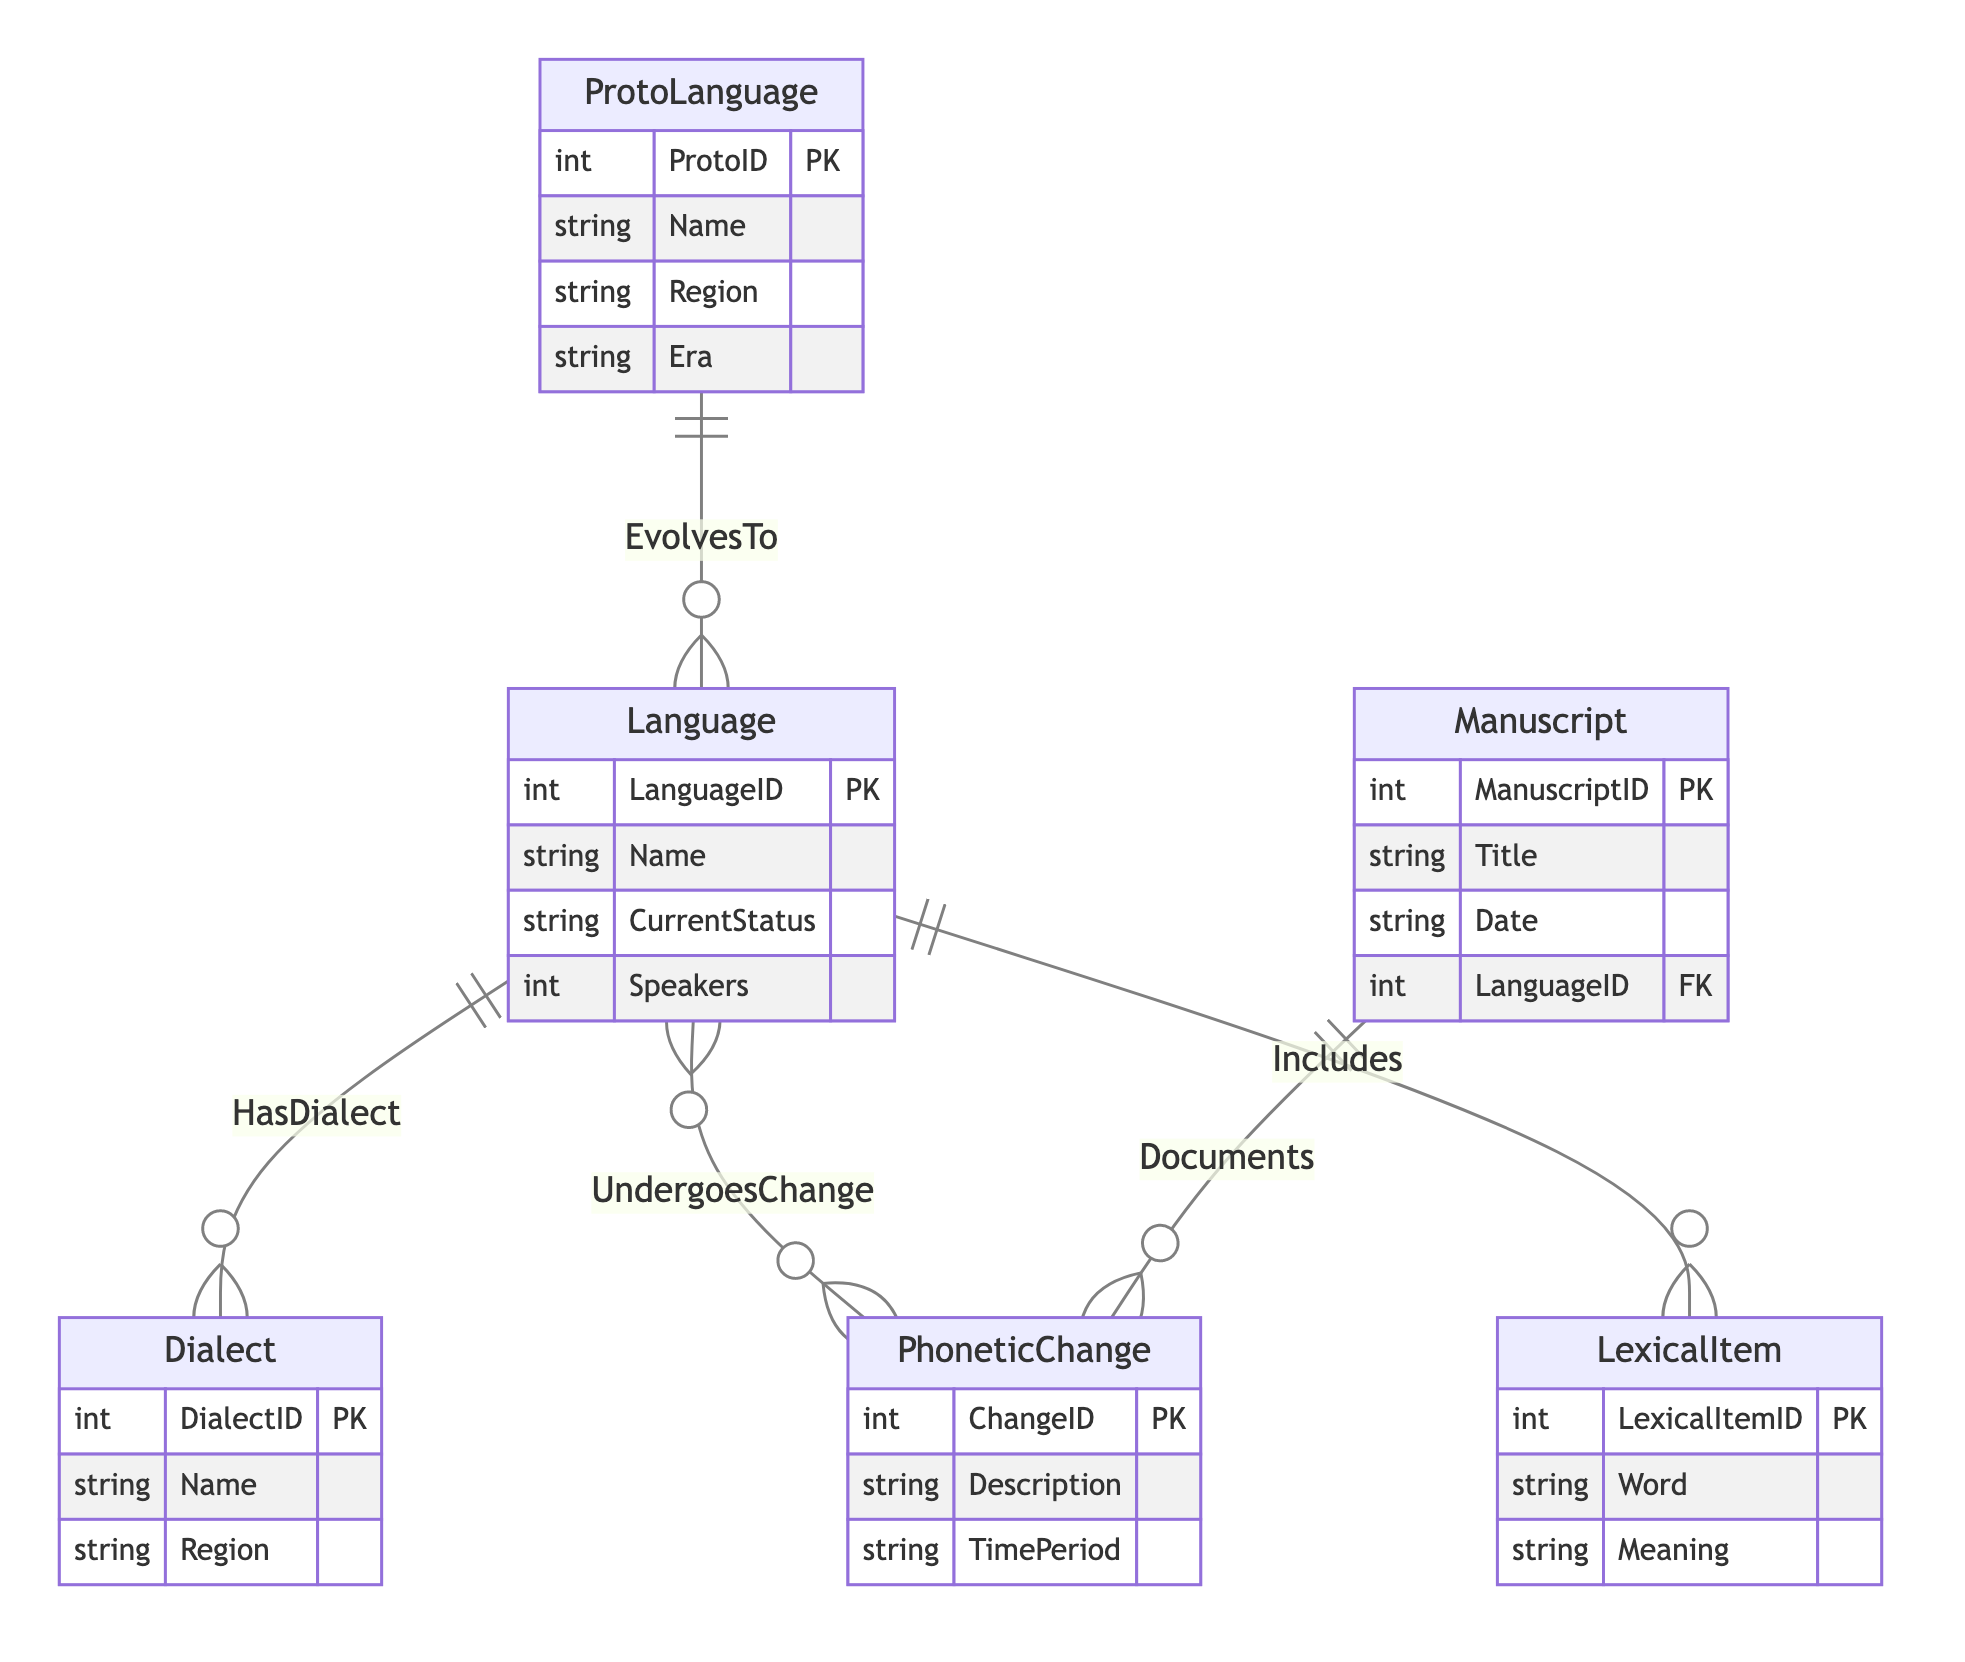What is the primary key of the ProtoLanguage entity? The primary key of the ProtoLanguage entity is ProtoID, as indicated in the diagram where it is marked as a primary key.
Answer: ProtoID How many relationships does the Language entity have? The Language entity has four relationships: it evolves to ProtoLanguage, has dialects, undergoes phonetic changes, and includes lexical items. Counting these gives a total of four relationships.
Answer: Four What is the relationship between Language and Dialect? The relationship between Language and Dialect is that Language has dialects, which is a one-to-many relationship. This means each Language can have multiple Dialects.
Answer: HasDialect What is the maximum number of PhoneticChanges a single Language can undergo? Since the relationship between Language and PhoneticChange is many-to-many, a single Language can undergo multiple PhoneticChanges, which theoretically could be unlimited. However, the specific maximum is not defined in the diagram.
Answer: Many How many attributes does the LexicalItem entity have? The LexicalItem entity has three attributes: LexicalItemID, Word, and Meaning. Count these to determine the total.
Answer: Three Which entity documents PhoneticChange? The Manuscript entity documents PhoneticChange, indicated by the one-to-many relationship where each Manuscript can document multiple PhoneticChanges.
Answer: Manuscript What is the Foreign Key of the Manuscript entity? The Foreign Key of the Manuscript entity is LanguageID, which establishes the link between the Manuscript and the Language it is associated with.
Answer: LanguageID What type of relationship is between Language and PhoneticChange? The relationship between Language and PhoneticChange is many-to-many, meaning that multiple Languages can undergo the same PhoneticChanges and vice versa.
Answer: Many-to-Many What is the attribute name that indicates the current status of a Language? The attribute that indicates the current status of a Language is CurrentStatus, as specified in the Language entity's attributes list.
Answer: CurrentStatus 